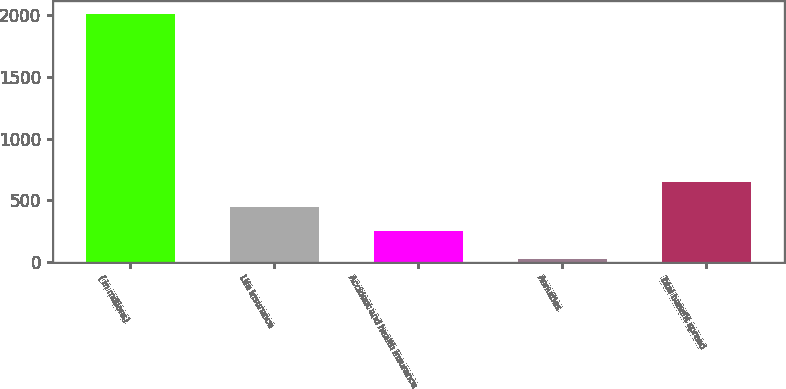Convert chart. <chart><loc_0><loc_0><loc_500><loc_500><bar_chart><fcel>( in millions)<fcel>Life insurance<fcel>Accident and health insurance<fcel>Annuities<fcel>Total benefit spread<nl><fcel>2010<fcel>450.5<fcel>252<fcel>25<fcel>649<nl></chart> 